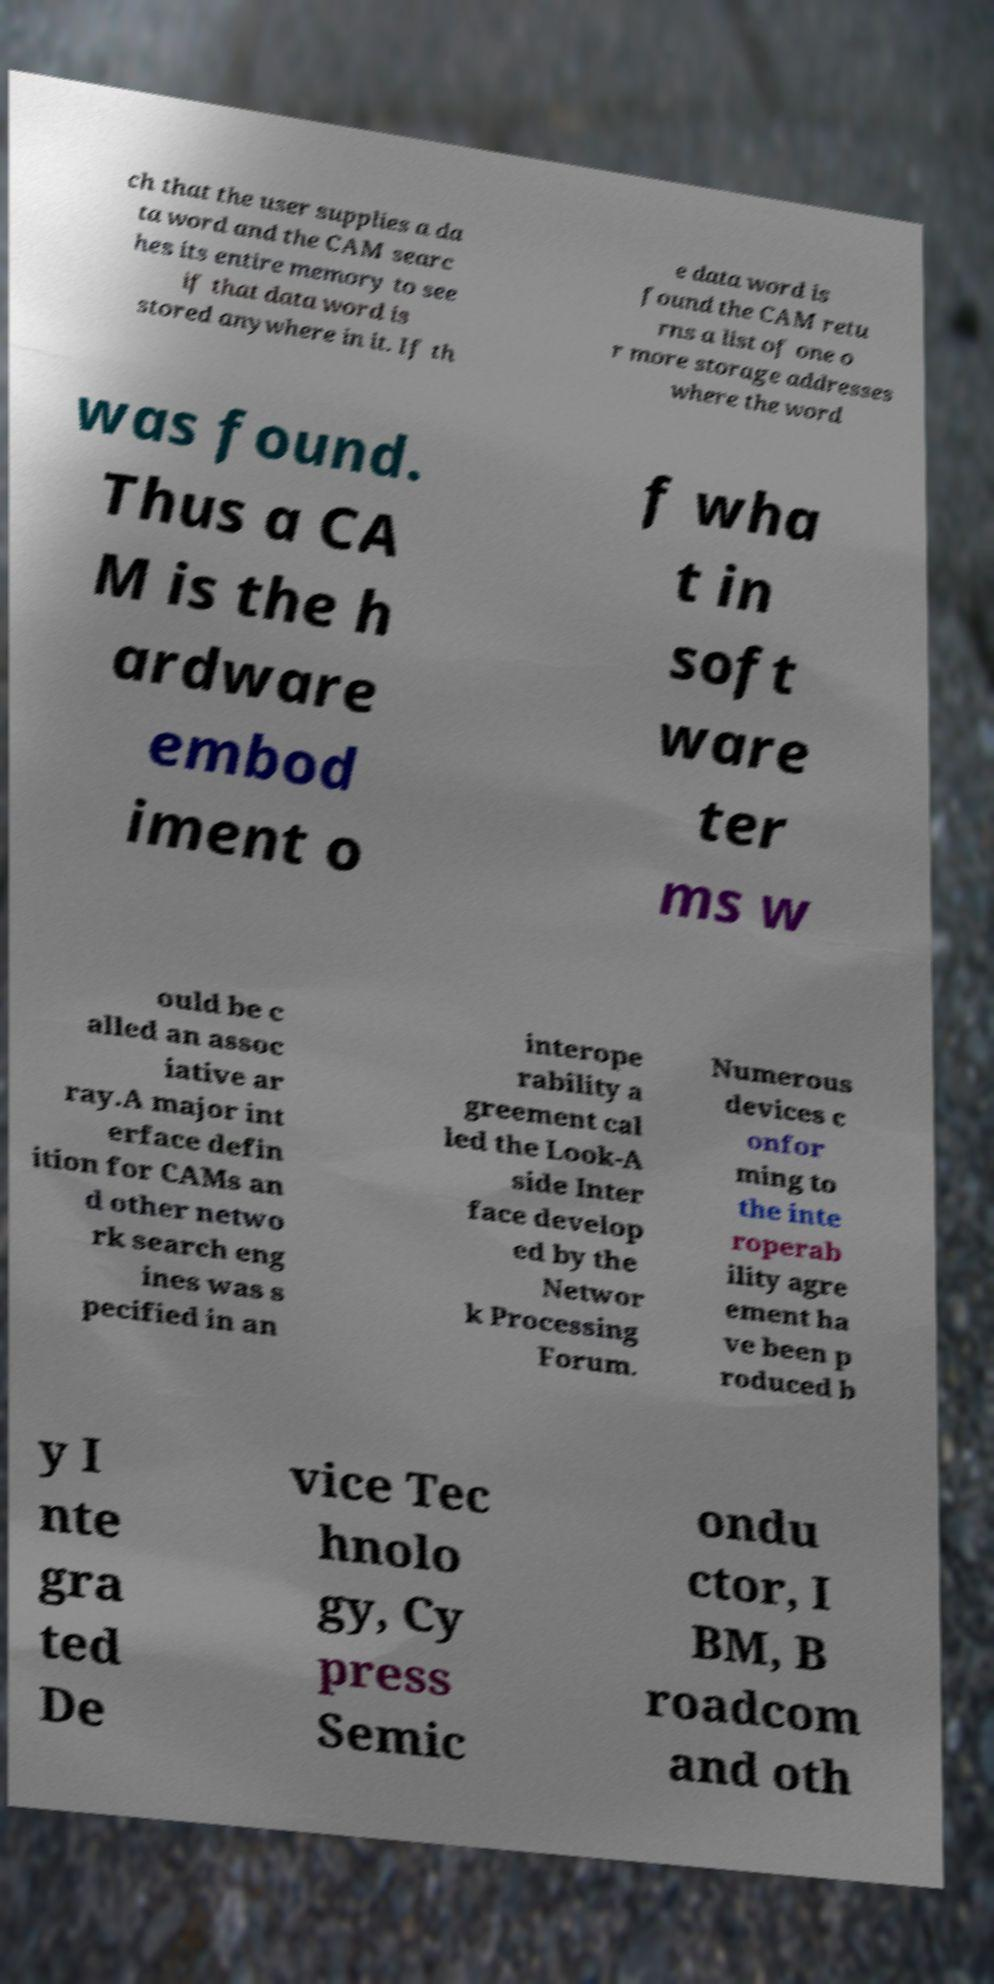Please identify and transcribe the text found in this image. ch that the user supplies a da ta word and the CAM searc hes its entire memory to see if that data word is stored anywhere in it. If th e data word is found the CAM retu rns a list of one o r more storage addresses where the word was found. Thus a CA M is the h ardware embod iment o f wha t in soft ware ter ms w ould be c alled an assoc iative ar ray.A major int erface defin ition for CAMs an d other netwo rk search eng ines was s pecified in an interope rability a greement cal led the Look-A side Inter face develop ed by the Networ k Processing Forum. Numerous devices c onfor ming to the inte roperab ility agre ement ha ve been p roduced b y I nte gra ted De vice Tec hnolo gy, Cy press Semic ondu ctor, I BM, B roadcom and oth 